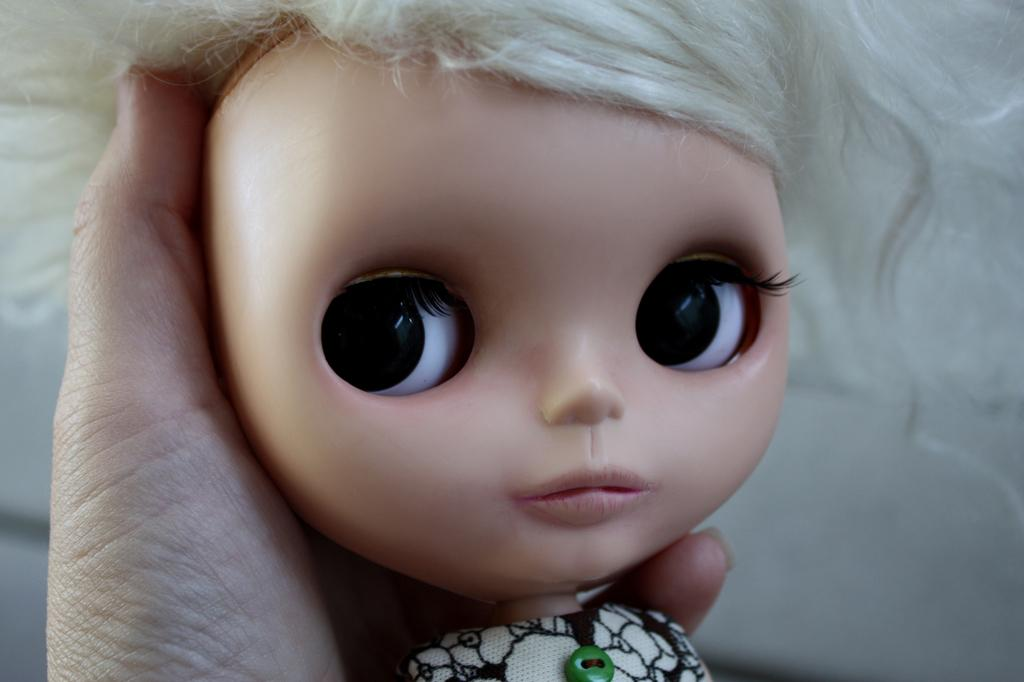What is the main subject of the image? There is a doll in the image. Who is holding the doll in the image? The doll is being held by a person. What type of stocking is the doll wearing in the image? The image does not show the doll wearing any stockings. Is there a club visible in the image? There is no club present in the image. 